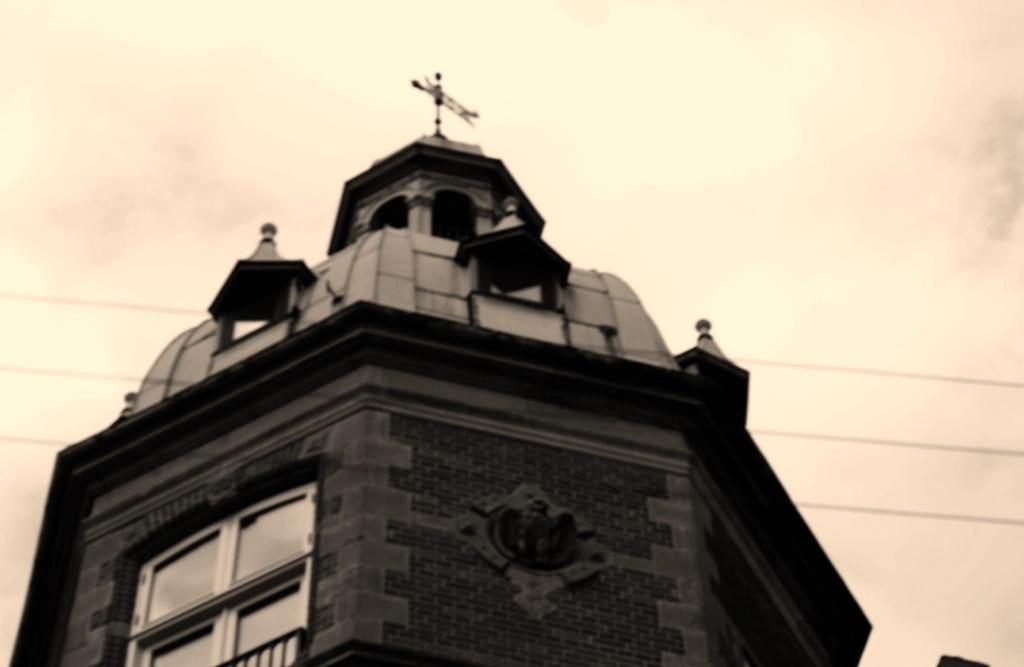What is the main subject in the middle of the image? There is a structure in the middle of the image. What can be seen in the sky at the top of the image? The sky is cloudy and visible at the top of the image. How many clover leaves can be seen growing on the structure in the image? There are no clover leaves present on the structure in the image. What unit of measurement is used to determine the growth of the structure in the image? The facts provided do not mention any specific unit of measurement for the structure's growth. 